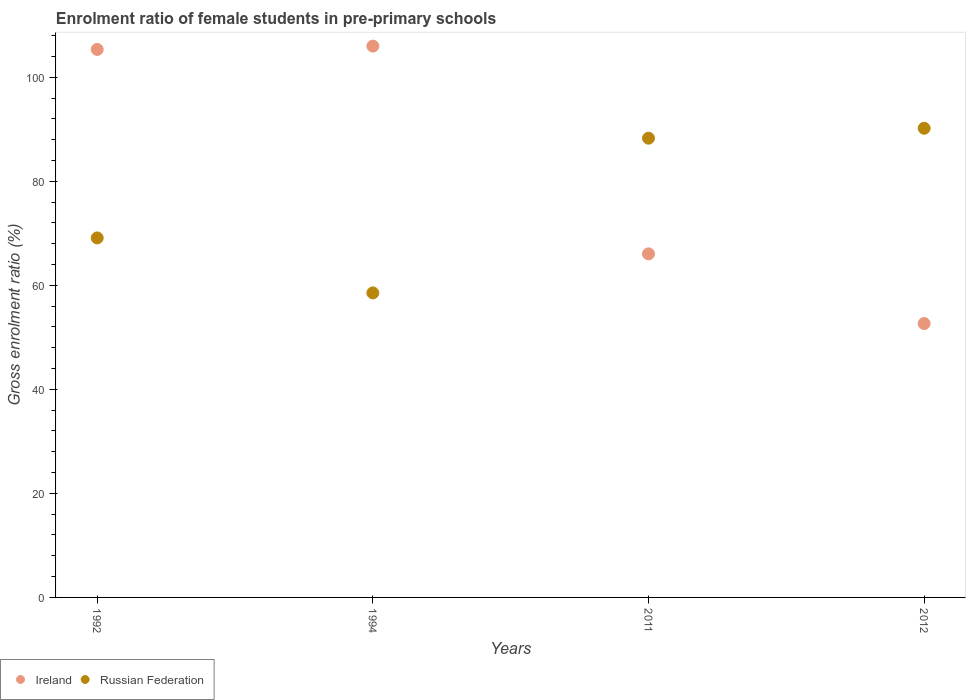What is the enrolment ratio of female students in pre-primary schools in Ireland in 1992?
Ensure brevity in your answer.  105.34. Across all years, what is the maximum enrolment ratio of female students in pre-primary schools in Russian Federation?
Offer a very short reply. 90.19. Across all years, what is the minimum enrolment ratio of female students in pre-primary schools in Russian Federation?
Your answer should be compact. 58.54. In which year was the enrolment ratio of female students in pre-primary schools in Russian Federation maximum?
Give a very brief answer. 2012. What is the total enrolment ratio of female students in pre-primary schools in Russian Federation in the graph?
Provide a succinct answer. 306.11. What is the difference between the enrolment ratio of female students in pre-primary schools in Ireland in 1992 and that in 2012?
Provide a succinct answer. 52.69. What is the difference between the enrolment ratio of female students in pre-primary schools in Ireland in 1994 and the enrolment ratio of female students in pre-primary schools in Russian Federation in 2012?
Provide a succinct answer. 15.79. What is the average enrolment ratio of female students in pre-primary schools in Ireland per year?
Your response must be concise. 82.5. In the year 2012, what is the difference between the enrolment ratio of female students in pre-primary schools in Russian Federation and enrolment ratio of female students in pre-primary schools in Ireland?
Offer a terse response. 37.53. In how many years, is the enrolment ratio of female students in pre-primary schools in Ireland greater than 16 %?
Make the answer very short. 4. What is the ratio of the enrolment ratio of female students in pre-primary schools in Ireland in 1994 to that in 2011?
Your response must be concise. 1.6. Is the difference between the enrolment ratio of female students in pre-primary schools in Russian Federation in 1992 and 2012 greater than the difference between the enrolment ratio of female students in pre-primary schools in Ireland in 1992 and 2012?
Provide a short and direct response. No. What is the difference between the highest and the second highest enrolment ratio of female students in pre-primary schools in Ireland?
Your answer should be very brief. 0.64. What is the difference between the highest and the lowest enrolment ratio of female students in pre-primary schools in Ireland?
Your answer should be very brief. 53.32. In how many years, is the enrolment ratio of female students in pre-primary schools in Ireland greater than the average enrolment ratio of female students in pre-primary schools in Ireland taken over all years?
Offer a very short reply. 2. How many dotlines are there?
Your answer should be compact. 2. How many years are there in the graph?
Keep it short and to the point. 4. What is the difference between two consecutive major ticks on the Y-axis?
Keep it short and to the point. 20. Does the graph contain any zero values?
Provide a succinct answer. No. Does the graph contain grids?
Offer a very short reply. No. Where does the legend appear in the graph?
Make the answer very short. Bottom left. How many legend labels are there?
Make the answer very short. 2. How are the legend labels stacked?
Ensure brevity in your answer.  Horizontal. What is the title of the graph?
Your answer should be very brief. Enrolment ratio of female students in pre-primary schools. What is the label or title of the X-axis?
Provide a short and direct response. Years. What is the Gross enrolment ratio (%) in Ireland in 1992?
Offer a very short reply. 105.34. What is the Gross enrolment ratio (%) of Russian Federation in 1992?
Provide a short and direct response. 69.1. What is the Gross enrolment ratio (%) in Ireland in 1994?
Provide a short and direct response. 105.98. What is the Gross enrolment ratio (%) in Russian Federation in 1994?
Provide a short and direct response. 58.54. What is the Gross enrolment ratio (%) of Ireland in 2011?
Offer a very short reply. 66.04. What is the Gross enrolment ratio (%) in Russian Federation in 2011?
Make the answer very short. 88.28. What is the Gross enrolment ratio (%) of Ireland in 2012?
Provide a short and direct response. 52.65. What is the Gross enrolment ratio (%) in Russian Federation in 2012?
Provide a succinct answer. 90.19. Across all years, what is the maximum Gross enrolment ratio (%) of Ireland?
Offer a very short reply. 105.98. Across all years, what is the maximum Gross enrolment ratio (%) of Russian Federation?
Your answer should be compact. 90.19. Across all years, what is the minimum Gross enrolment ratio (%) in Ireland?
Ensure brevity in your answer.  52.65. Across all years, what is the minimum Gross enrolment ratio (%) of Russian Federation?
Your answer should be compact. 58.54. What is the total Gross enrolment ratio (%) of Ireland in the graph?
Offer a terse response. 330.01. What is the total Gross enrolment ratio (%) of Russian Federation in the graph?
Make the answer very short. 306.11. What is the difference between the Gross enrolment ratio (%) of Ireland in 1992 and that in 1994?
Your answer should be very brief. -0.64. What is the difference between the Gross enrolment ratio (%) in Russian Federation in 1992 and that in 1994?
Provide a short and direct response. 10.56. What is the difference between the Gross enrolment ratio (%) of Ireland in 1992 and that in 2011?
Offer a terse response. 39.3. What is the difference between the Gross enrolment ratio (%) in Russian Federation in 1992 and that in 2011?
Provide a short and direct response. -19.18. What is the difference between the Gross enrolment ratio (%) of Ireland in 1992 and that in 2012?
Your response must be concise. 52.69. What is the difference between the Gross enrolment ratio (%) in Russian Federation in 1992 and that in 2012?
Provide a short and direct response. -21.08. What is the difference between the Gross enrolment ratio (%) of Ireland in 1994 and that in 2011?
Provide a short and direct response. 39.93. What is the difference between the Gross enrolment ratio (%) of Russian Federation in 1994 and that in 2011?
Your response must be concise. -29.74. What is the difference between the Gross enrolment ratio (%) in Ireland in 1994 and that in 2012?
Provide a short and direct response. 53.32. What is the difference between the Gross enrolment ratio (%) of Russian Federation in 1994 and that in 2012?
Make the answer very short. -31.65. What is the difference between the Gross enrolment ratio (%) in Ireland in 2011 and that in 2012?
Provide a succinct answer. 13.39. What is the difference between the Gross enrolment ratio (%) in Russian Federation in 2011 and that in 2012?
Keep it short and to the point. -1.91. What is the difference between the Gross enrolment ratio (%) in Ireland in 1992 and the Gross enrolment ratio (%) in Russian Federation in 1994?
Your answer should be very brief. 46.8. What is the difference between the Gross enrolment ratio (%) of Ireland in 1992 and the Gross enrolment ratio (%) of Russian Federation in 2011?
Your answer should be very brief. 17.06. What is the difference between the Gross enrolment ratio (%) in Ireland in 1992 and the Gross enrolment ratio (%) in Russian Federation in 2012?
Give a very brief answer. 15.15. What is the difference between the Gross enrolment ratio (%) in Ireland in 1994 and the Gross enrolment ratio (%) in Russian Federation in 2011?
Provide a short and direct response. 17.7. What is the difference between the Gross enrolment ratio (%) of Ireland in 1994 and the Gross enrolment ratio (%) of Russian Federation in 2012?
Give a very brief answer. 15.79. What is the difference between the Gross enrolment ratio (%) in Ireland in 2011 and the Gross enrolment ratio (%) in Russian Federation in 2012?
Keep it short and to the point. -24.14. What is the average Gross enrolment ratio (%) of Ireland per year?
Your answer should be very brief. 82.5. What is the average Gross enrolment ratio (%) of Russian Federation per year?
Ensure brevity in your answer.  76.53. In the year 1992, what is the difference between the Gross enrolment ratio (%) in Ireland and Gross enrolment ratio (%) in Russian Federation?
Offer a terse response. 36.24. In the year 1994, what is the difference between the Gross enrolment ratio (%) in Ireland and Gross enrolment ratio (%) in Russian Federation?
Offer a terse response. 47.44. In the year 2011, what is the difference between the Gross enrolment ratio (%) in Ireland and Gross enrolment ratio (%) in Russian Federation?
Provide a short and direct response. -22.24. In the year 2012, what is the difference between the Gross enrolment ratio (%) of Ireland and Gross enrolment ratio (%) of Russian Federation?
Provide a succinct answer. -37.53. What is the ratio of the Gross enrolment ratio (%) in Ireland in 1992 to that in 1994?
Provide a short and direct response. 0.99. What is the ratio of the Gross enrolment ratio (%) of Russian Federation in 1992 to that in 1994?
Provide a short and direct response. 1.18. What is the ratio of the Gross enrolment ratio (%) of Ireland in 1992 to that in 2011?
Make the answer very short. 1.59. What is the ratio of the Gross enrolment ratio (%) of Russian Federation in 1992 to that in 2011?
Keep it short and to the point. 0.78. What is the ratio of the Gross enrolment ratio (%) in Ireland in 1992 to that in 2012?
Your response must be concise. 2. What is the ratio of the Gross enrolment ratio (%) in Russian Federation in 1992 to that in 2012?
Make the answer very short. 0.77. What is the ratio of the Gross enrolment ratio (%) of Ireland in 1994 to that in 2011?
Your response must be concise. 1.6. What is the ratio of the Gross enrolment ratio (%) in Russian Federation in 1994 to that in 2011?
Your answer should be compact. 0.66. What is the ratio of the Gross enrolment ratio (%) of Ireland in 1994 to that in 2012?
Your response must be concise. 2.01. What is the ratio of the Gross enrolment ratio (%) in Russian Federation in 1994 to that in 2012?
Keep it short and to the point. 0.65. What is the ratio of the Gross enrolment ratio (%) of Ireland in 2011 to that in 2012?
Provide a short and direct response. 1.25. What is the ratio of the Gross enrolment ratio (%) in Russian Federation in 2011 to that in 2012?
Offer a terse response. 0.98. What is the difference between the highest and the second highest Gross enrolment ratio (%) in Ireland?
Provide a short and direct response. 0.64. What is the difference between the highest and the second highest Gross enrolment ratio (%) of Russian Federation?
Make the answer very short. 1.91. What is the difference between the highest and the lowest Gross enrolment ratio (%) of Ireland?
Keep it short and to the point. 53.32. What is the difference between the highest and the lowest Gross enrolment ratio (%) of Russian Federation?
Your answer should be very brief. 31.65. 